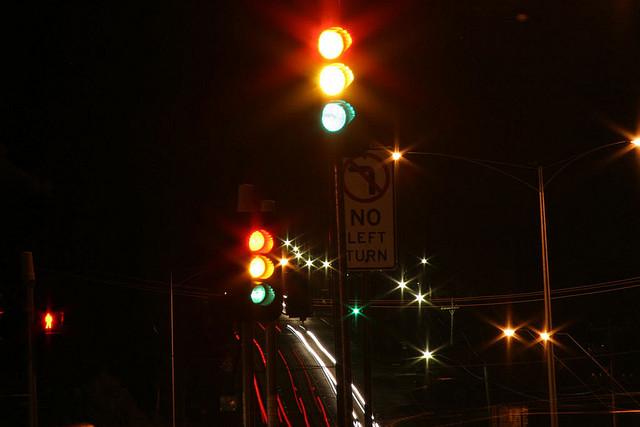Are there many cars seen?
Keep it brief. Yes. Are there many lights lit up?
Short answer required. Yes. What color are the traffic lights?
Be succinct. Red, yellow and green. How many traffic lights can be seen?
Answer briefly. 2. What does the sign say?
Keep it brief. No left turn. What color is the traffic light?
Be succinct. Red, yellow and green. 